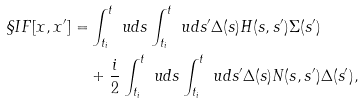<formula> <loc_0><loc_0><loc_500><loc_500>\S I F [ x , x ^ { \prime } ] = & \int _ { t _ { i } } ^ { t } \ u d s \int _ { t _ { i } } ^ { t } \ u d { s ^ { \prime } } \Delta ( s ) H ( s , s ^ { \prime } ) \Sigma ( s ^ { \prime } ) \\ & + \frac { i } { 2 } \int _ { t _ { i } } ^ { t } \ u d s \int _ { t _ { i } } ^ { t } \ u d { s ^ { \prime } } \Delta ( s ) N ( s , s ^ { \prime } ) \Delta ( s ^ { \prime } ) ,</formula> 